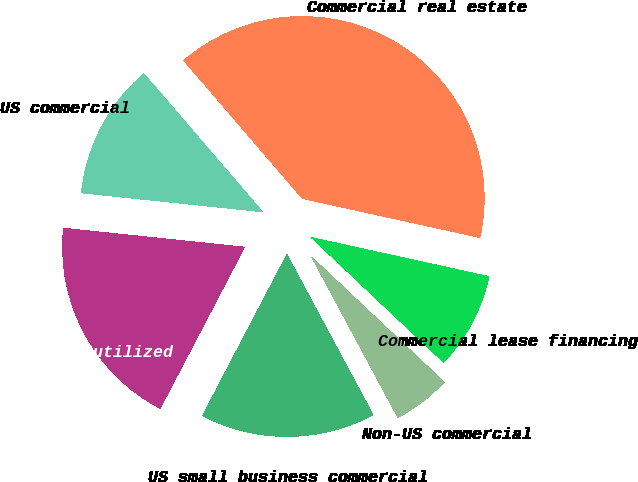<chart> <loc_0><loc_0><loc_500><loc_500><pie_chart><fcel>US commercial<fcel>Commercial real estate<fcel>Commercial lease financing<fcel>Non-US commercial<fcel>US small business commercial<fcel>Total commercial utilized<nl><fcel>12.05%<fcel>39.74%<fcel>8.59%<fcel>5.12%<fcel>15.52%<fcel>18.98%<nl></chart> 